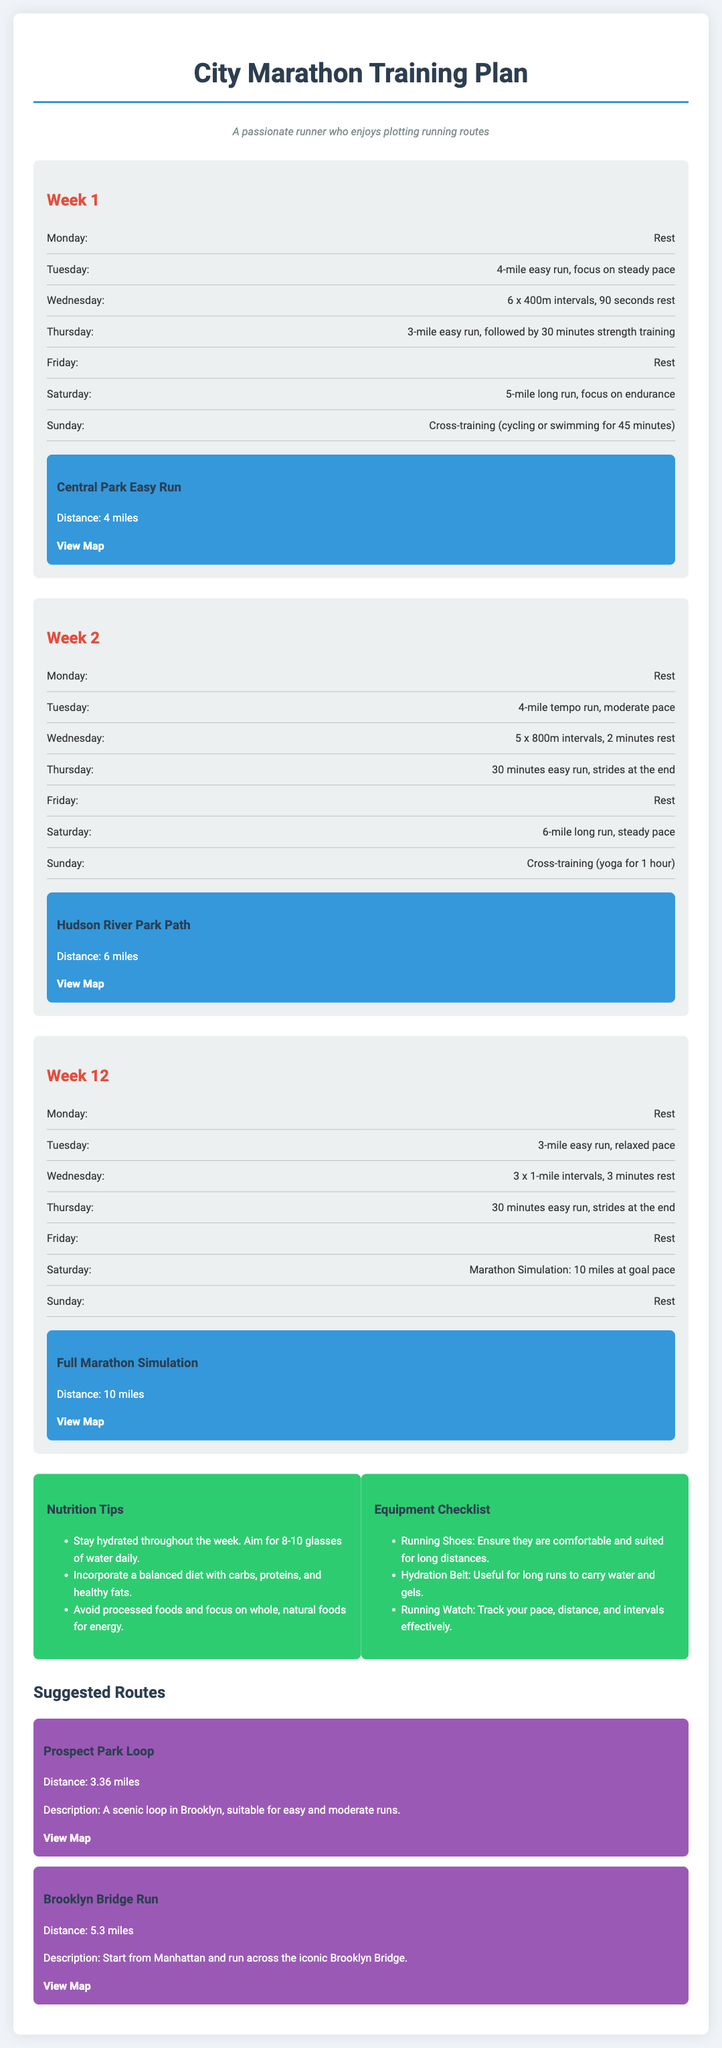what is the distance of the Central Park Easy Run? The distance is stated in the route map section for Week 1.
Answer: 4 miles what workout is scheduled for Wednesday of Week 2? The workout is detailed in the workout section for Week 2.
Answer: 5 x 800m intervals, 2 minutes rest how many miles is the Marathon Simulation in Week 12? This information can be found under the workout section for Week 12.
Answer: 10 miles what is the main focus of the Saturday run in Week 1? The focus is specified in the workout details for the Saturday run in Week 1.
Answer: Endurance how many sets of intervals are included in Week 1? Details on the types of workouts can be found under Week 1 and the workout days.
Answer: 6 x 400m what type of cross-training is suggested for Sunday in Week 2? The type of cross-training is mentioned in the workout details for Week 2.
Answer: Yoga what is one tip mentioned in the Nutrition Tips section? The Nutrition Tips provide specific advice located at the bottom of the document.
Answer: Stay hydrated throughout the week how many suggested routes are listed at the end of the document? This can be found in the Suggested Routes section, detailing how many routes are featured.
Answer: 2 what is advised to use during long runs according to the Equipment Checklist? The Equipment Checklist provides specific items that are recommended for long runs.
Answer: Hydration Belt 